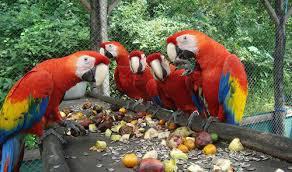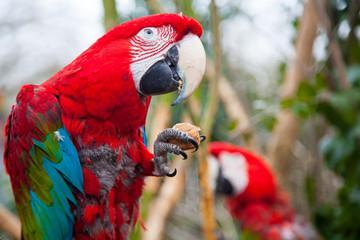The first image is the image on the left, the second image is the image on the right. For the images displayed, is the sentence "The right image contains no more than one parrot." factually correct? Answer yes or no. No. 